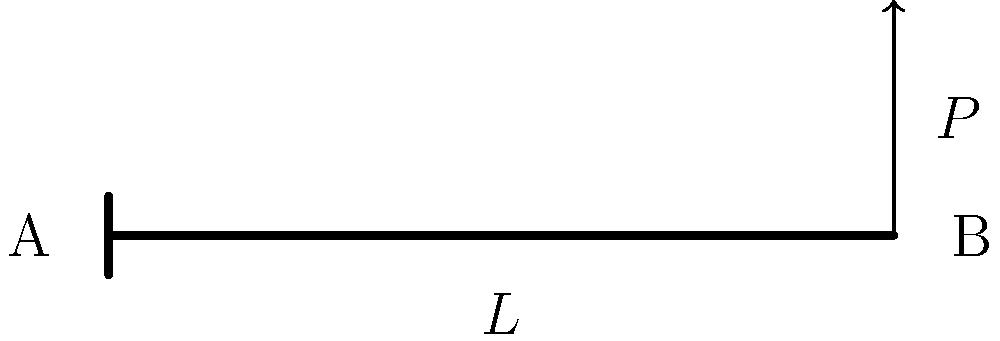As a collaborating artist working on a project involving structural elements, you need to understand the basics of beam deflection. Consider a cantilever beam of length $L$ with a point load $P$ at its free end, as shown in the figure. The beam has a modulus of elasticity $E$ and moment of inertia $I$. What are the expressions for the slope $\theta$ at the free end and the maximum deflection $y_{max}$ of the beam? Let's approach this step-by-step:

1) For a cantilever beam with a point load at the free end, we can use the following formulas:

   Slope at free end: $\theta = \frac{PL^2}{2EI}$
   Maximum deflection: $y_{max} = \frac{PL^3}{3EI}$

2) The slope $\theta$ is measured in radians and occurs at the free end (point B in the figure).

3) The maximum deflection $y_{max}$ also occurs at the free end (point B).

4) These formulas are derived from the differential equation of the elastic curve:

   $EI\frac{d^2y}{dx^2} = M(x)$

   Where $M(x)$ is the bending moment at any point $x$ along the beam.

5) For this loading condition, the bending moment varies linearly from $M = PL$ at the fixed end to $M = 0$ at the free end.

6) By integrating the differential equation twice and applying the boundary conditions (y = 0 and dy/dx = 0 at the fixed end), we arrive at the given formulas.

7) Note that these formulas assume small deflections and linear elastic behavior of the material.
Answer: $\theta = \frac{PL^2}{2EI}$, $y_{max} = \frac{PL^3}{3EI}$ 